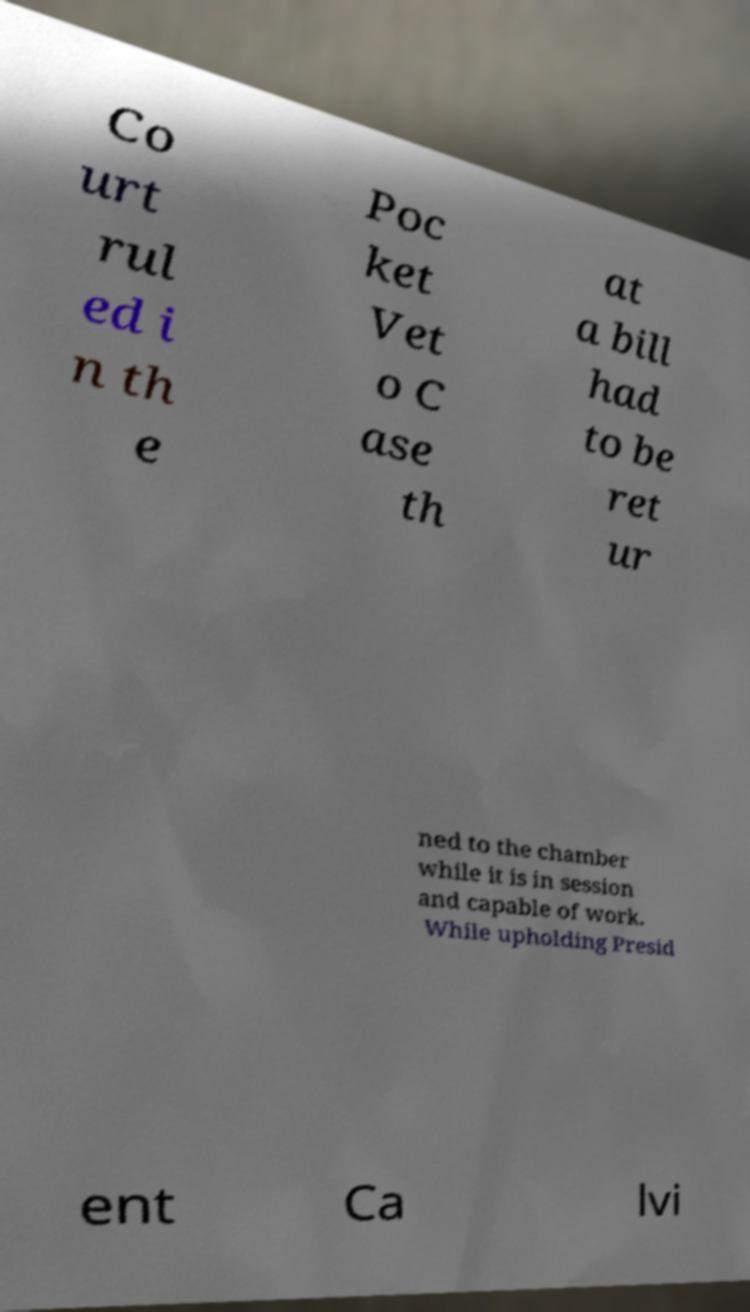Please read and relay the text visible in this image. What does it say? Co urt rul ed i n th e Poc ket Vet o C ase th at a bill had to be ret ur ned to the chamber while it is in session and capable of work. While upholding Presid ent Ca lvi 